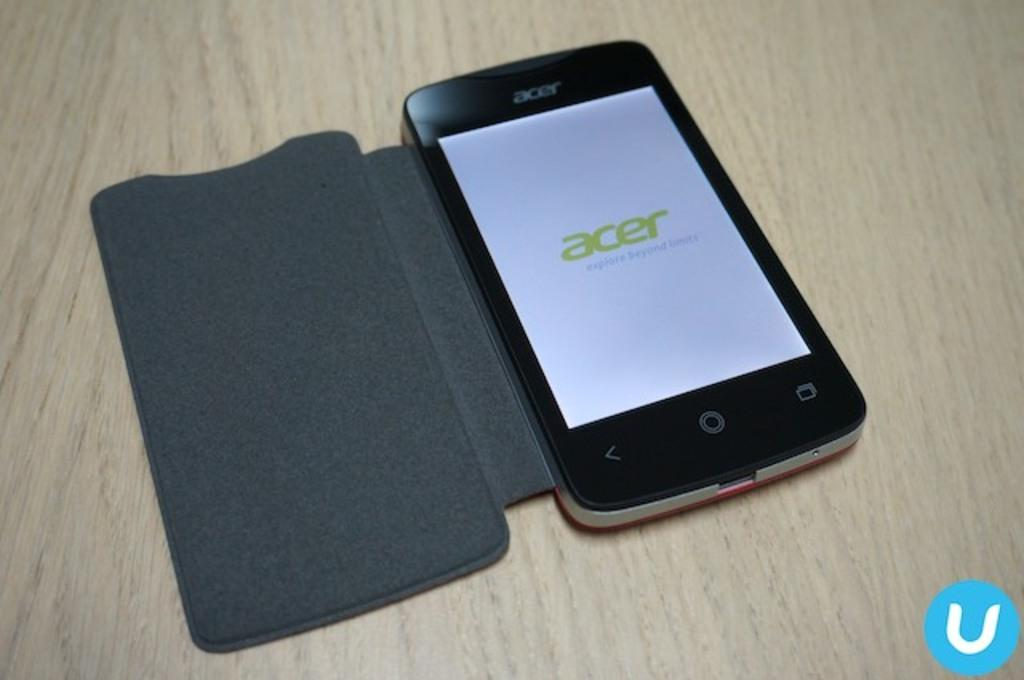<image>
Share a concise interpretation of the image provided. An open phone which has the word Acer on the screen. 